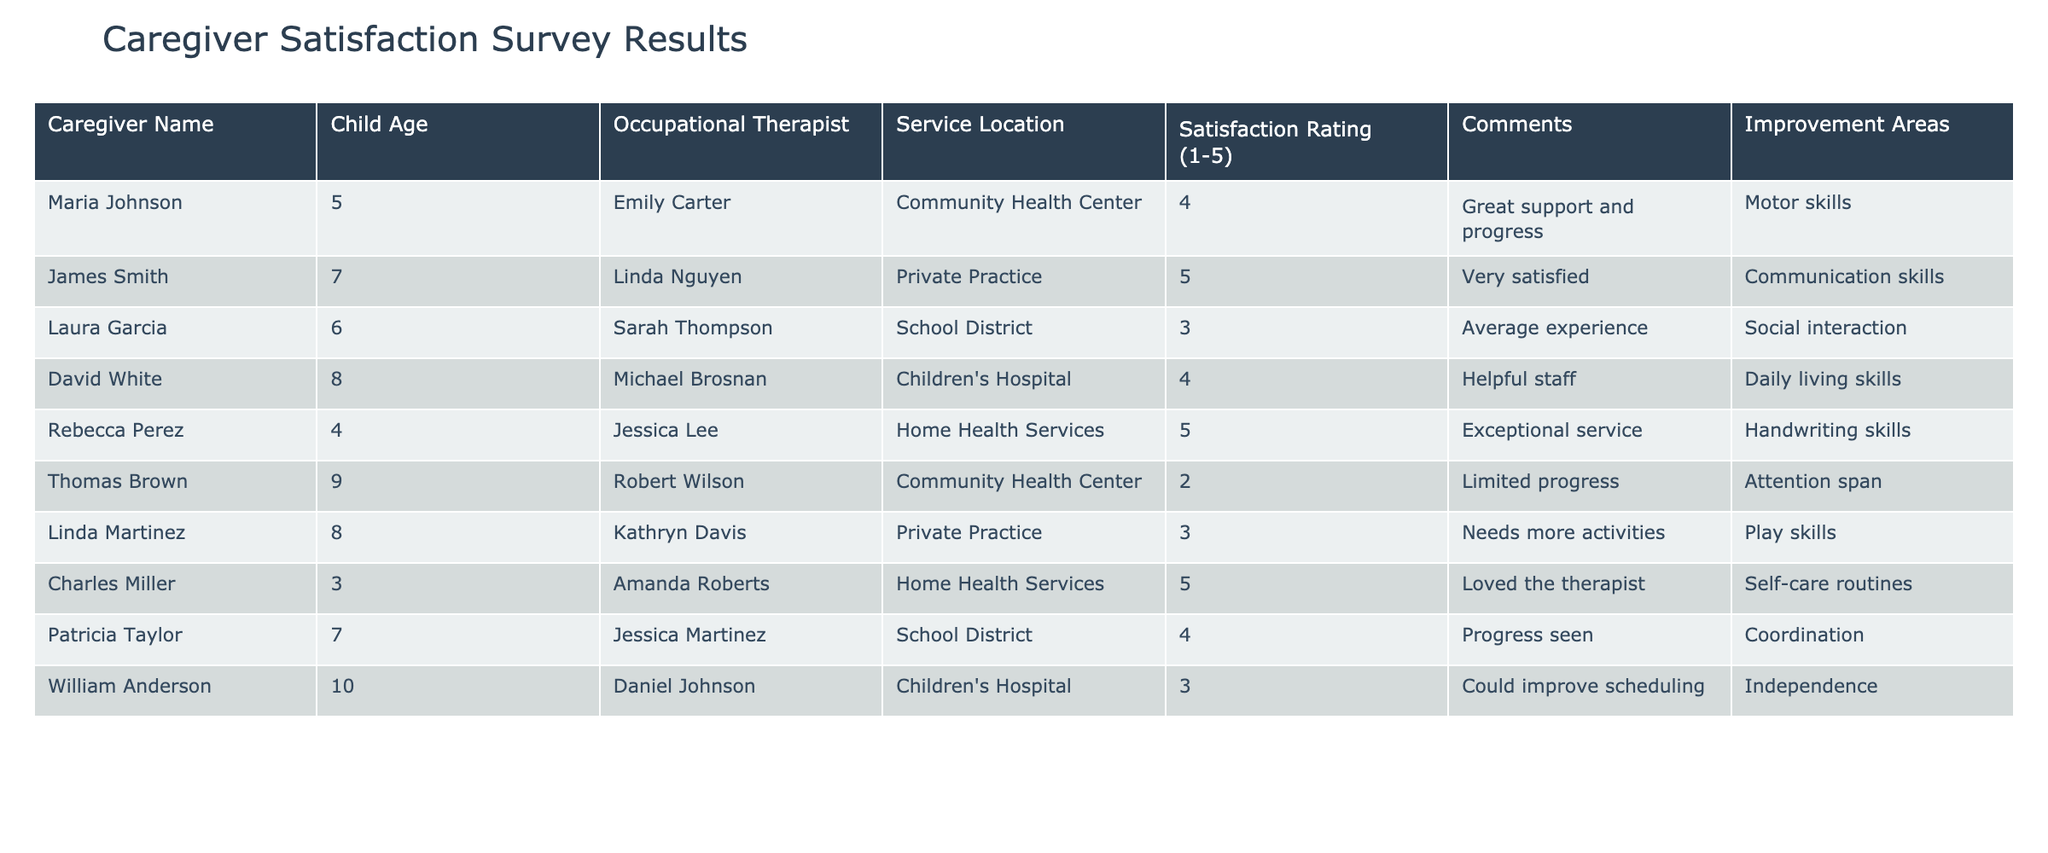What is the satisfaction rating of Rebecca Perez? Rebecca Perez's satisfaction rating is listed in the table under the "Satisfaction Rating (1-5)” column. It shows a rating of 5.
Answer: 5 Which child viewed their experience with therapy as average? The table lists Laura Garcia, who is 6 years old, as having a satisfaction rating of 3, which indicates an average experience.
Answer: Laura Garcia How many caregivers rated their experience as 5? To find this, we look at the "Satisfaction Rating (1-5)" column and count the instances of the rating 5. There are three instances: Rebecca Perez, James Smith, and Charles Miller.
Answer: 3 What is the most common improvement area mentioned? The table shows various improvement areas listed in the “Improvement Areas” column. To determine the most common, we look for repeated entries. "Motor skills" appears once, and "Daily living skills" also appears once. No area is repeated, indicating no common improvement area.
Answer: No common improvement area Which therapy service location has the lowest satisfaction rating? We examine the "Service Location" and "Satisfaction Rating (1-5)" columns together. Thomas Brown's case shows a satisfaction rating of 2 at the Community Health Center. This is the lowest rating listed in the table.
Answer: Community Health Center Calculate the average satisfaction rating from the survey results. To find the average, we first sum the satisfaction ratings: 4 + 5 + 3 + 4 + 5 + 2 + 3 + 5 + 4 + 3 = 43. Then, divide by the number of ratings (10) to find the average: 43/10 = 4.3.
Answer: 4.3 Did any caregiver express dissatisfaction with their child's therapy? To determine this, we look for ratings of 2 or lower in the "Satisfaction Rating (1-5)" column. Only Thomas Brown provided a rating of 2, indicating dissatisfaction with progress.
Answer: Yes Which occupational therapist received a rating of 5? We can identify specific therapists by checking the "Occupational Therapist" column against the "Satisfaction Rating (1-5)." Emily Carter, Linda Nguyen, and Amanda Roberts received ratings of 5.
Answer: Emily Carter, Linda Nguyen, Amanda Roberts What percentage of caregivers rated their satisfaction as 4 or higher? First, we count the number of caregivers with ratings of 4 or higher: 4 (Emily, James, David, Rebecca, Patricia). There are 5 such ratings. With 10 total responses, the percentage is (5/10) * 100 = 50%.
Answer: 50% Are there any comments specifically mentioning a need for more activities? We check the "Comments" column for mentions of "more activities." The comment by Linda Martinez indicates a need for more activities, confirming there is at least one such comment.
Answer: Yes 